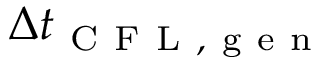Convert formula to latex. <formula><loc_0><loc_0><loc_500><loc_500>\Delta t _ { C F L , g e n }</formula> 